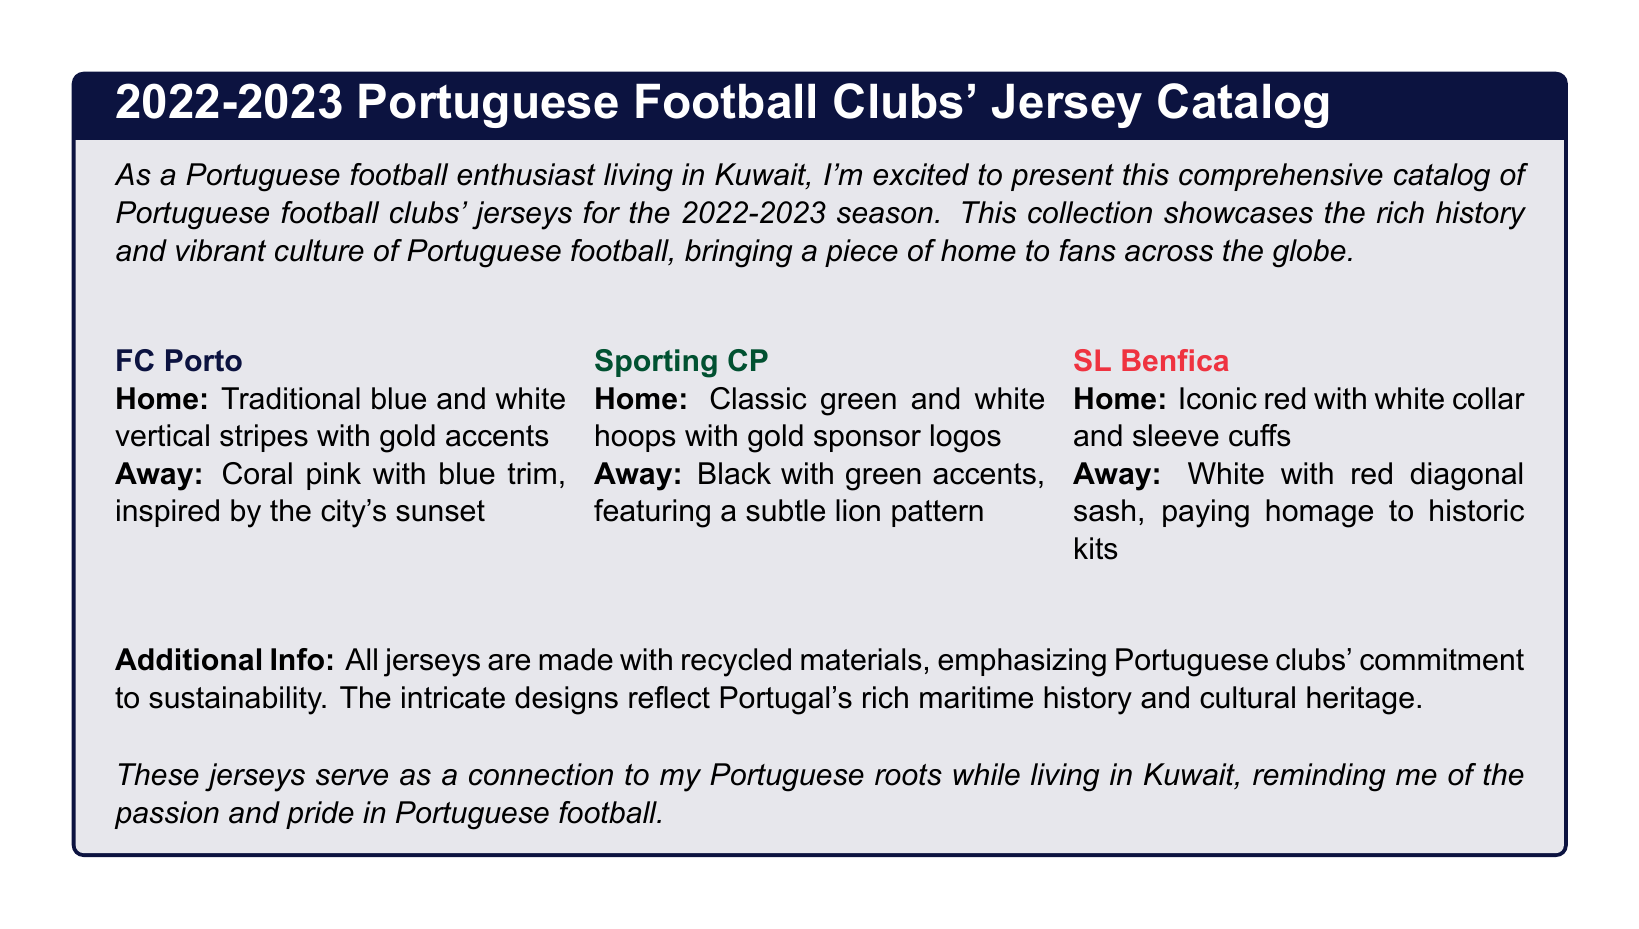What color are FC Porto's home stripes? FC Porto's home kit features traditional blue and white vertical stripes.
Answer: Blue and white What is the away kit color for Sporting CP? Sporting CP's away kit is black with green accents.
Answer: Black How many clubs are featured in the catalog? The document presents jerseys for three clubs, listed in the text.
Answer: Three What color is SL Benfica's home jersey? The home jersey of SL Benfica is an iconic red color.
Answer: Red What theme inspired FC Porto's away jersey? The coral pink away jersey is inspired by the city's sunset.
Answer: Sunset What material are the jerseys made from? The document mentions that all jerseys are made with recycled materials.
Answer: Recycled materials What is the accent color on Sporting CP's home kit? The home kit for Sporting CP features gold sponsor logos as accent colors.
Answer: Gold Which club's away kit features a lion pattern? The away kit for Sporting CP features a subtle lion pattern.
Answer: Sporting CP What visual design does SL Benfica's away kit pay homage to? The away kit's design pays homage to historic kits with a red diagonal sash.
Answer: Historic kits 